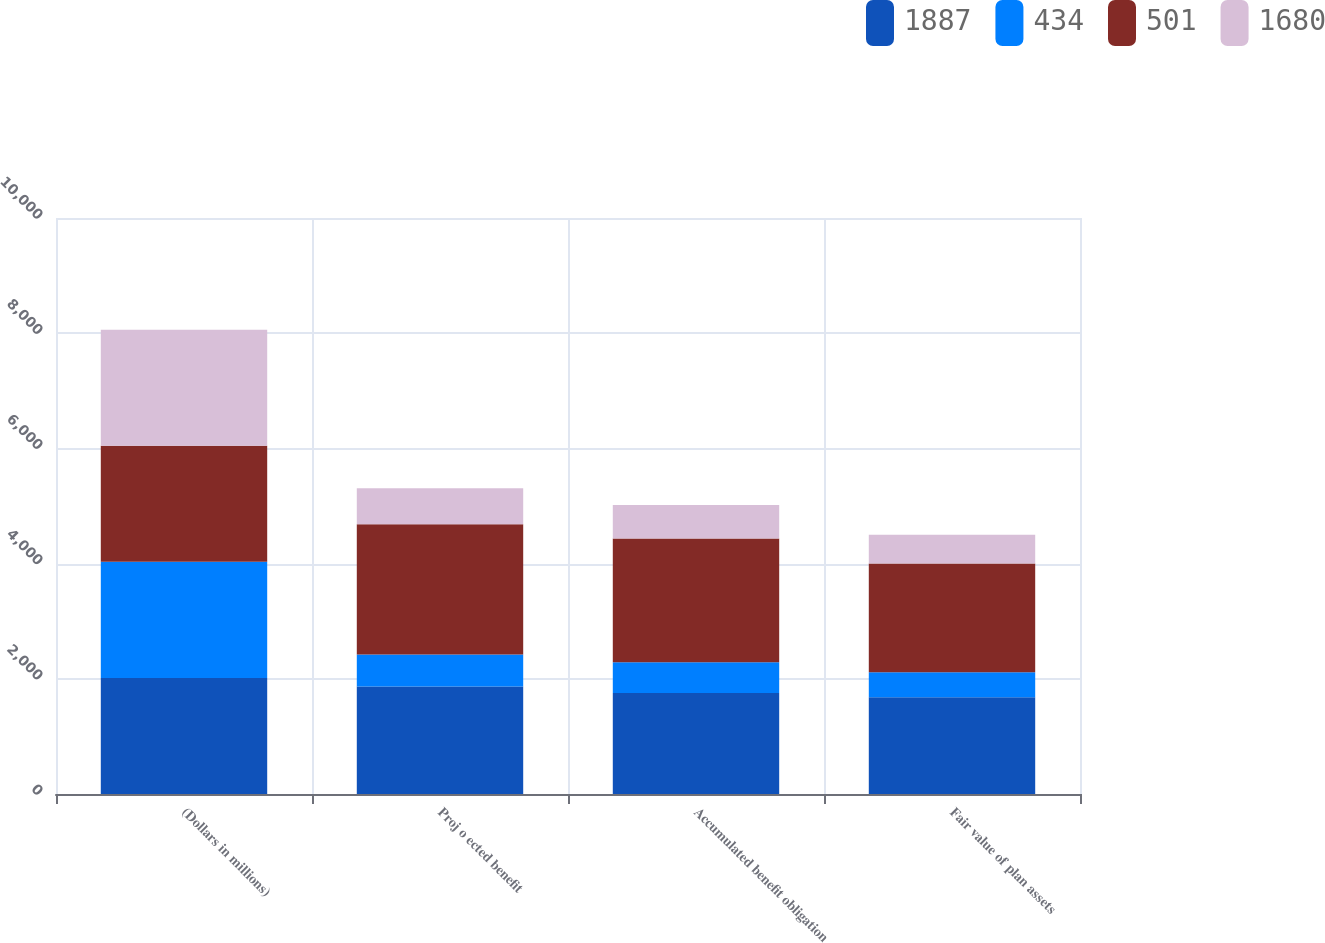Convert chart to OTSL. <chart><loc_0><loc_0><loc_500><loc_500><stacked_bar_chart><ecel><fcel>(Dollars in millions)<fcel>Proj o ected benefit<fcel>Accumulated benefit obligation<fcel>Fair value of plan assets<nl><fcel>1887<fcel>2016<fcel>1865<fcel>1754<fcel>1680<nl><fcel>434<fcel>2016<fcel>557<fcel>535<fcel>434<nl><fcel>501<fcel>2015<fcel>2262<fcel>2146<fcel>1887<nl><fcel>1680<fcel>2015<fcel>622<fcel>584<fcel>501<nl></chart> 